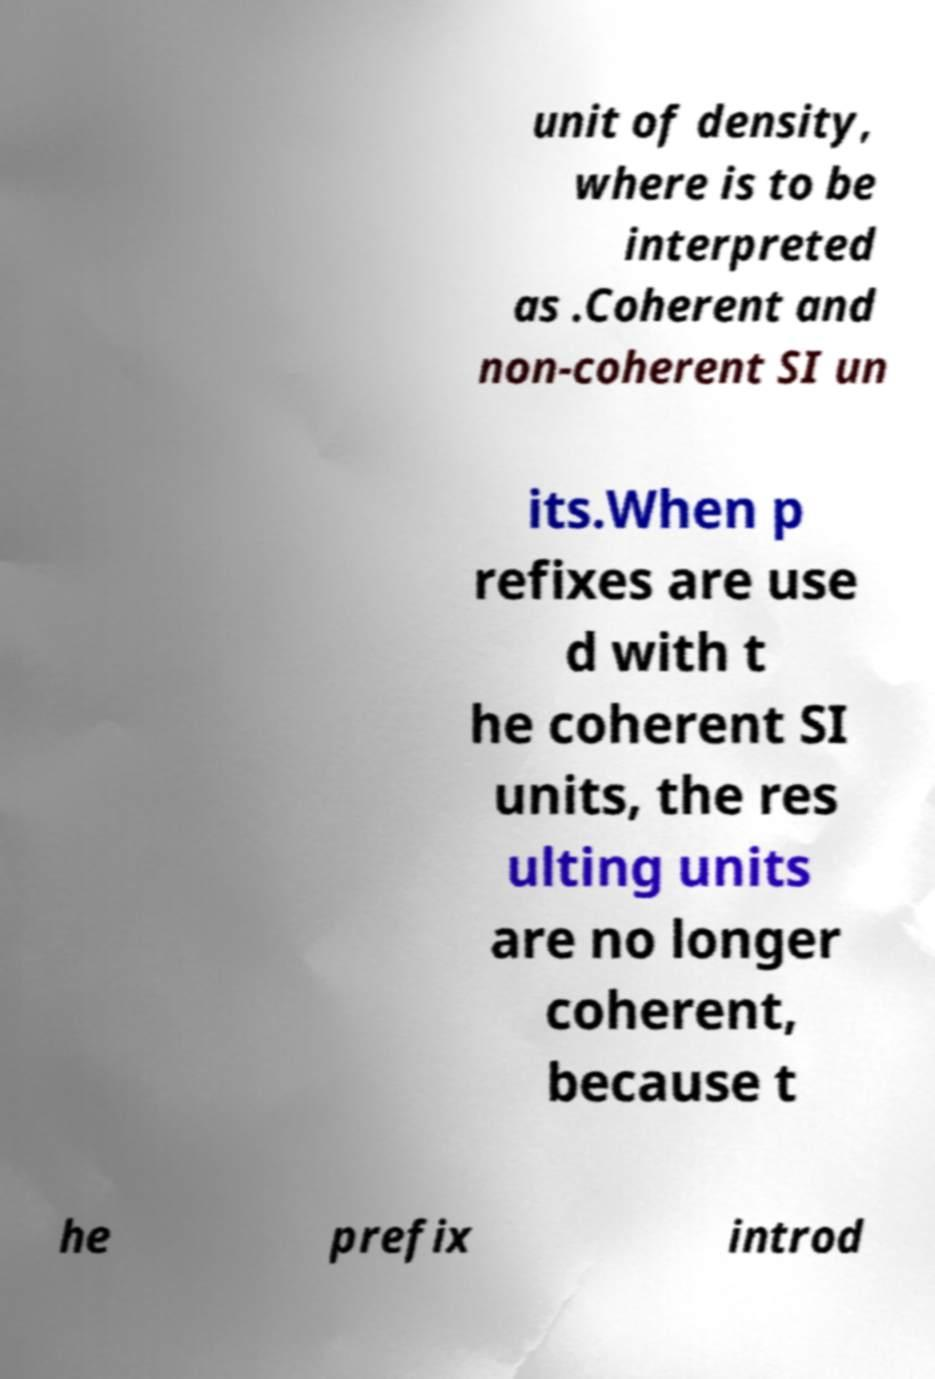Can you read and provide the text displayed in the image?This photo seems to have some interesting text. Can you extract and type it out for me? unit of density, where is to be interpreted as .Coherent and non-coherent SI un its.When p refixes are use d with t he coherent SI units, the res ulting units are no longer coherent, because t he prefix introd 